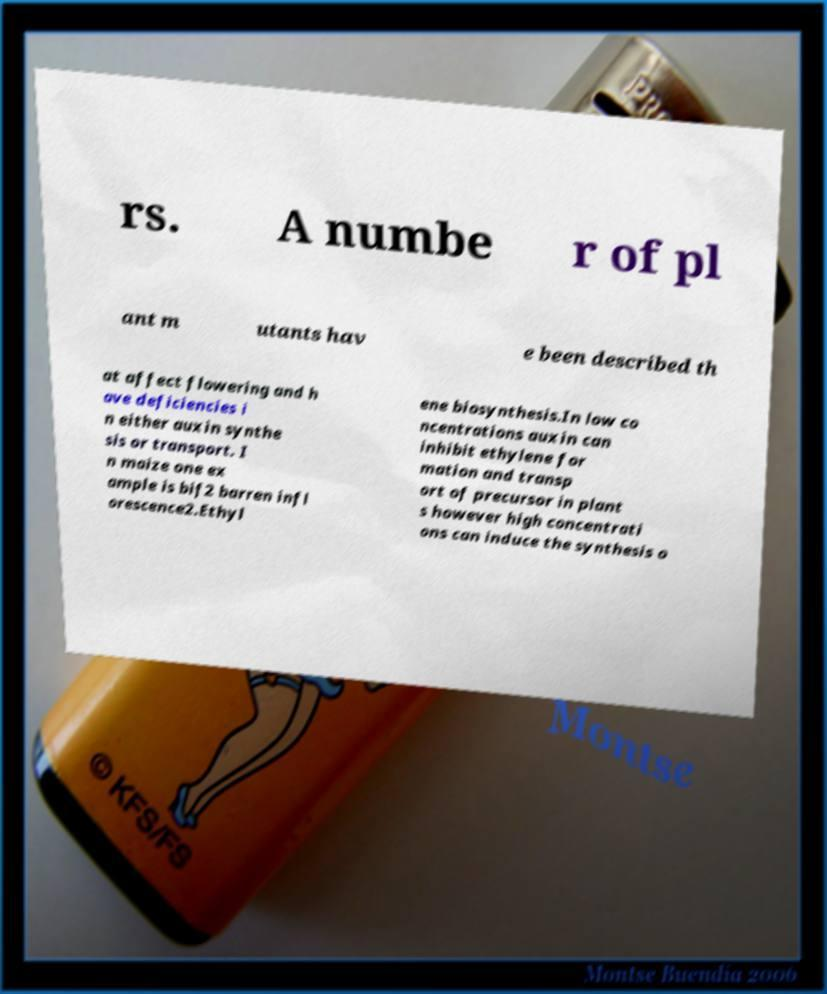Please identify and transcribe the text found in this image. rs. A numbe r of pl ant m utants hav e been described th at affect flowering and h ave deficiencies i n either auxin synthe sis or transport. I n maize one ex ample is bif2 barren infl orescence2.Ethyl ene biosynthesis.In low co ncentrations auxin can inhibit ethylene for mation and transp ort of precursor in plant s however high concentrati ons can induce the synthesis o 